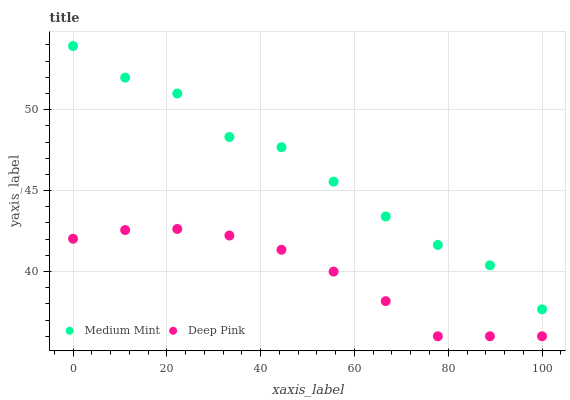Does Deep Pink have the minimum area under the curve?
Answer yes or no. Yes. Does Medium Mint have the maximum area under the curve?
Answer yes or no. Yes. Does Deep Pink have the maximum area under the curve?
Answer yes or no. No. Is Deep Pink the smoothest?
Answer yes or no. Yes. Is Medium Mint the roughest?
Answer yes or no. Yes. Is Deep Pink the roughest?
Answer yes or no. No. Does Deep Pink have the lowest value?
Answer yes or no. Yes. Does Medium Mint have the highest value?
Answer yes or no. Yes. Does Deep Pink have the highest value?
Answer yes or no. No. Is Deep Pink less than Medium Mint?
Answer yes or no. Yes. Is Medium Mint greater than Deep Pink?
Answer yes or no. Yes. Does Deep Pink intersect Medium Mint?
Answer yes or no. No. 